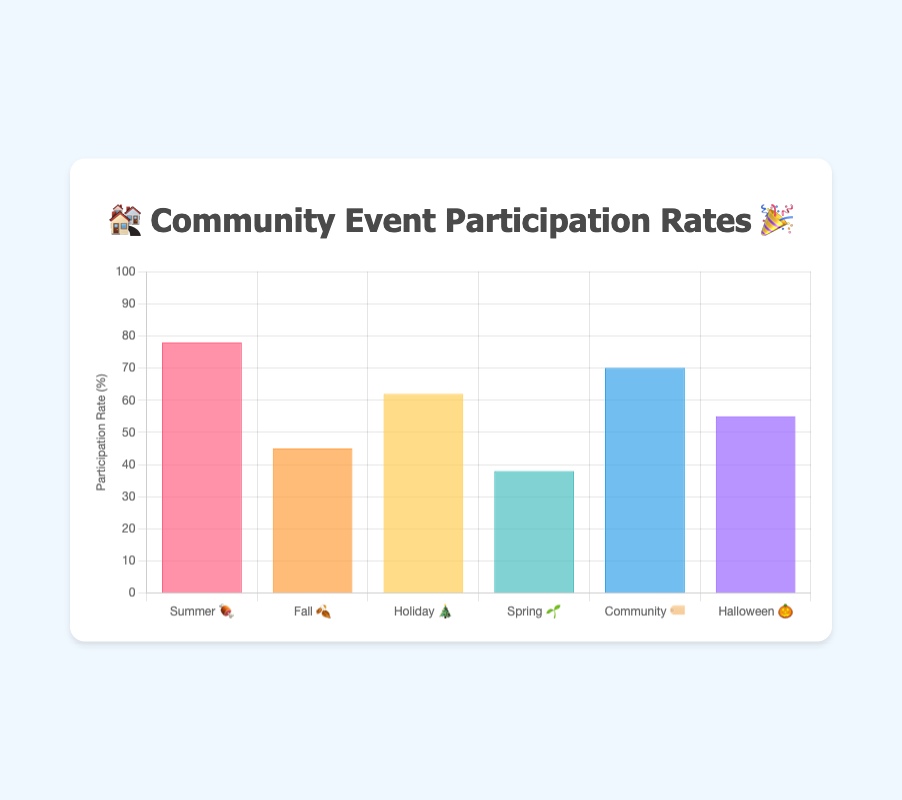What event in October has a higher participation rate? 🎃 or 🍂? The participation rate for the Halloween Parade 🎃 in October is 55%, while the Fall Cleanup Day 🍂 also in October has a participation rate of 45%. Comparing these two, the Halloween Parade has the higher rate.
Answer: 🎃 Which event had the highest participation rate? By examining the participation rates, the Summer Block Party 🍖 in July has the highest at 78%.
Answer: 🍖 Order the events from lowest to highest participation rate. List the participation rates from the dataset: Spring Garden Workshop 🌱 (38%), Fall Cleanup Day 🍂 (45%), Halloween Parade 🎃 (55%), Holiday Lights Contest 🎄 (62%), Community Yard Sale 🏷️ (70%), Summer Block Party 🍖 (78%), then order them accordingly.
Answer: 🌱, 🍂, 🎃, 🎄, 🏷️, 🍖 What is the average participation rate of the events? Sum up the participation rates (78 + 45 + 62 + 38 + 70 + 55 = 348), then divide by the number of events (6).
Answer: 58% How does the Summer Block Party 🍖 compare to the Community Yard Sale 🏷️ in terms of participation rate? The participation rate for the Summer Block Party 🍖 is 78%, while the Community Yard Sale 🏷️ has a 70% rate. The Summer Block Party has a higher participation by 8%.
Answer: 8% higher Which event had the lowest participation rate and what was it? 🌱 Among the data provided: Spring Garden Workshop 🌱 had the lowest participation rate at 38%.
Answer: 🌱 How many events have participation rates above 60%? Identify the events with participation rates greater than 60%: Summer Block Party 🍖 (78%), Holiday Lights Contest 🎄 (62%), Community Yard Sale 🏷️ (70%). There are 3 such events.
Answer: 3 By how much does the participation rate of the Spring Garden Workshop 🌱 differ from the Fall Cleanup Day 🍂? Spring Garden Workshop 🌱 has a 38% participation rate, while Fall Cleanup Day 🍂 has 45%. The difference is 7%.
Answer: 7% What month has the highest participation rate and for which event? Looking at the participation rates, the highest rate is 78% in July for the Summer Block Party 🍖.
Answer: July, 🍖 What is the combined participation rate of all events in October? The participation rates for October events are Fall Cleanup Day 🍂 (45%) and Halloween Parade 🎃 (55%). Combined these make 100%.
Answer: 100% 